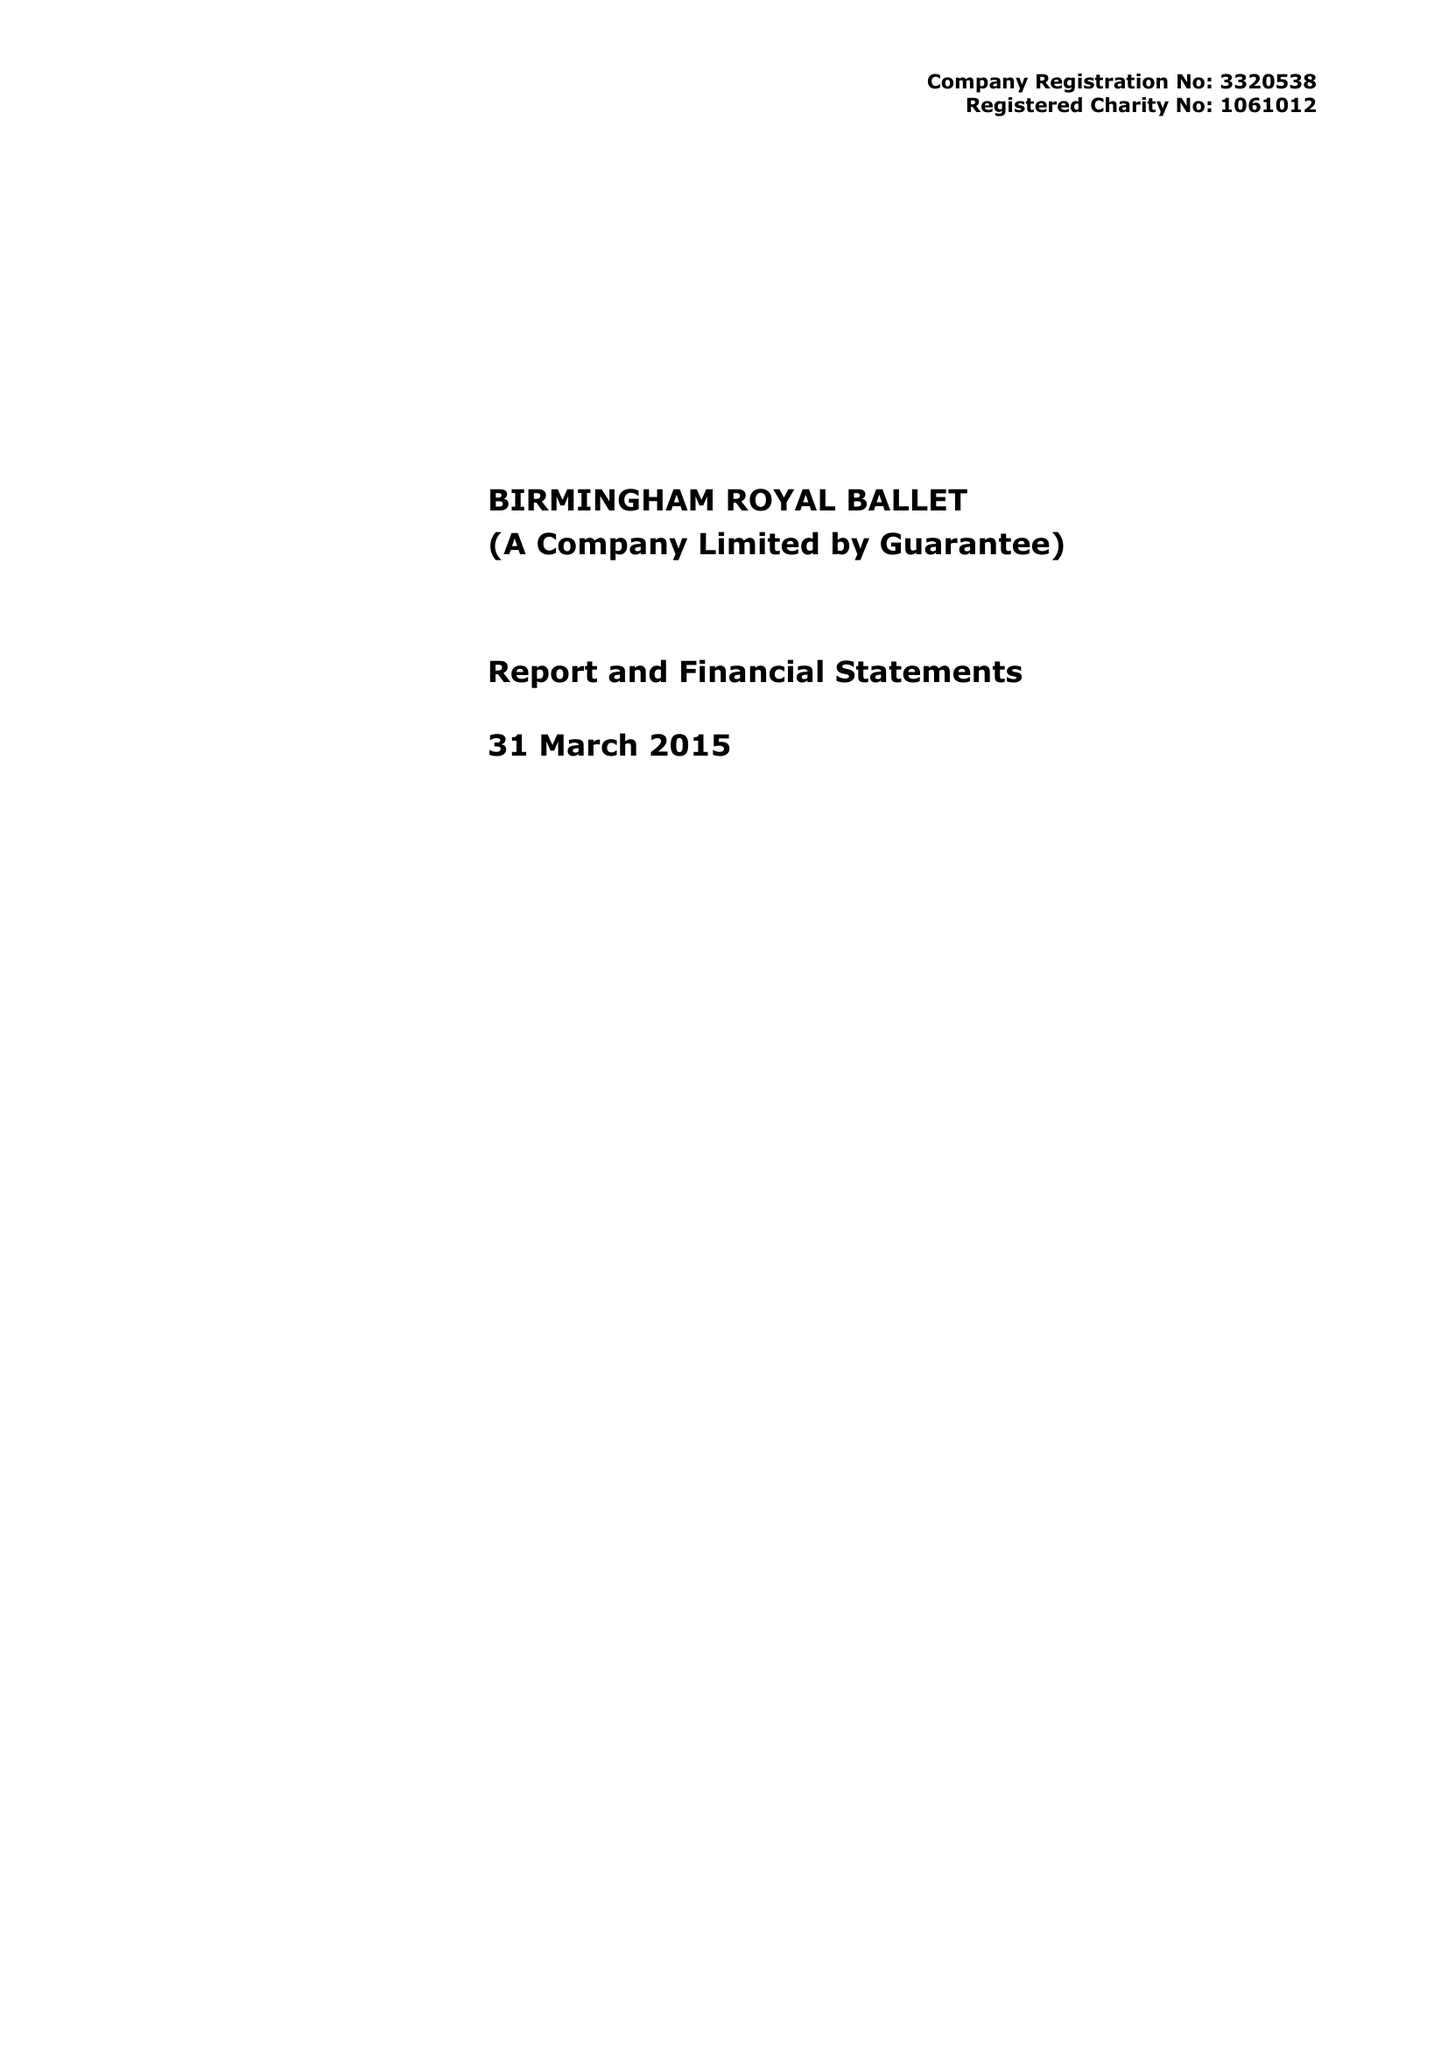What is the value for the charity_name?
Answer the question using a single word or phrase. Birmingham Royal Ballet 